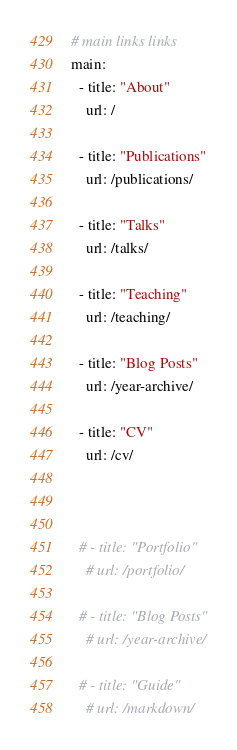Convert code to text. <code><loc_0><loc_0><loc_500><loc_500><_YAML_># main links links
main:
  - title: "About"
    url: /
    
  - title: "Publications"
    url: /publications/

  - title: "Talks"
    url: /talks/    

  - title: "Teaching"
    url: /teaching/    
 
  - title: "Blog Posts"
    url: /year-archive/ 
    
  - title: "CV"
    url: /cv/
    

    
  # - title: "Portfolio"
    # url: /portfolio/
        
  # - title: "Blog Posts"
    # url: /year-archive/
    
  # - title: "Guide"
    # url: /markdown/ 
</code> 